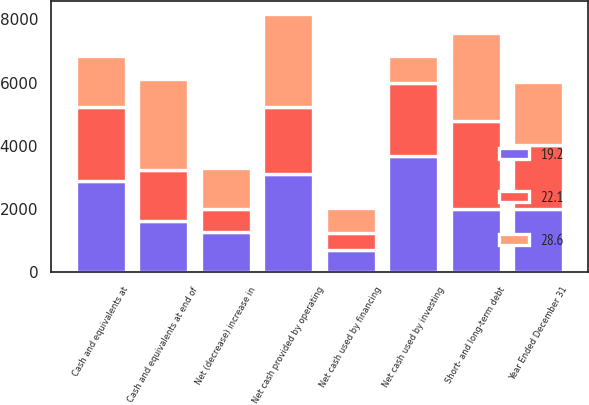Convert chart to OTSL. <chart><loc_0><loc_0><loc_500><loc_500><stacked_bar_chart><ecel><fcel>Year Ended December 31<fcel>Net cash provided by operating<fcel>Net cash used by investing<fcel>Net cash used by financing<fcel>Net (decrease) increase in<fcel>Cash and equivalents at<fcel>Cash and equivalents at end of<fcel>Short- and long-term debt<nl><fcel>19.2<fcel>2008<fcel>3110<fcel>3662<fcel>718<fcel>1270<fcel>2891<fcel>1621<fcel>2007<nl><fcel>28.6<fcel>2007<fcel>2925<fcel>852<fcel>786<fcel>1287<fcel>1604<fcel>2891<fcel>2791<nl><fcel>22.1<fcel>2006<fcel>2128<fcel>2316<fcel>539<fcel>727<fcel>2331<fcel>1604<fcel>2781<nl></chart> 